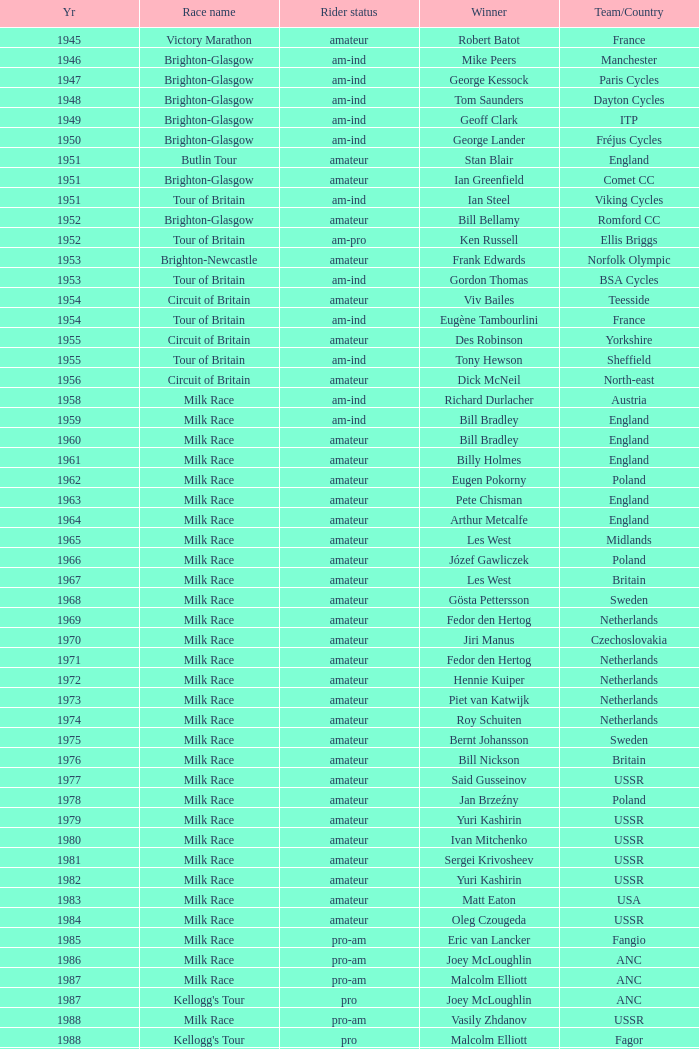What is the latest year when Phil Anderson won? 1993.0. 